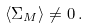<formula> <loc_0><loc_0><loc_500><loc_500>\langle \Sigma _ { M } \rangle \neq 0 \, .</formula> 